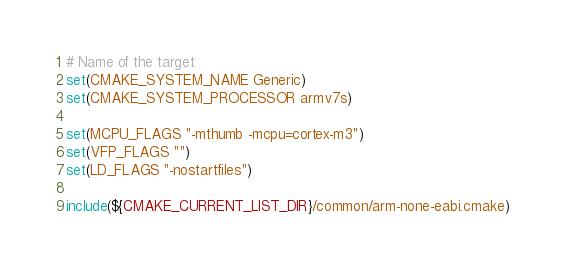Convert code to text. <code><loc_0><loc_0><loc_500><loc_500><_CMake_># Name of the target
set(CMAKE_SYSTEM_NAME Generic)
set(CMAKE_SYSTEM_PROCESSOR armv7s)

set(MCPU_FLAGS "-mthumb -mcpu=cortex-m3")
set(VFP_FLAGS "")
set(LD_FLAGS "-nostartfiles")

include(${CMAKE_CURRENT_LIST_DIR}/common/arm-none-eabi.cmake)
</code> 